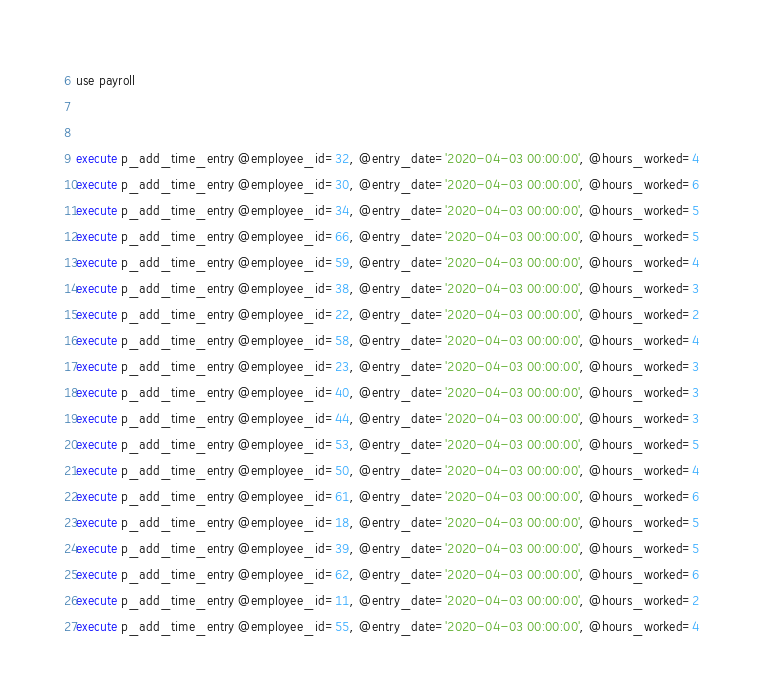<code> <loc_0><loc_0><loc_500><loc_500><_SQL_>use payroll


execute p_add_time_entry @employee_id=32, @entry_date='2020-04-03 00:00:00', @hours_worked=4
execute p_add_time_entry @employee_id=30, @entry_date='2020-04-03 00:00:00', @hours_worked=6
execute p_add_time_entry @employee_id=34, @entry_date='2020-04-03 00:00:00', @hours_worked=5
execute p_add_time_entry @employee_id=66, @entry_date='2020-04-03 00:00:00', @hours_worked=5
execute p_add_time_entry @employee_id=59, @entry_date='2020-04-03 00:00:00', @hours_worked=4
execute p_add_time_entry @employee_id=38, @entry_date='2020-04-03 00:00:00', @hours_worked=3
execute p_add_time_entry @employee_id=22, @entry_date='2020-04-03 00:00:00', @hours_worked=2
execute p_add_time_entry @employee_id=58, @entry_date='2020-04-03 00:00:00', @hours_worked=4
execute p_add_time_entry @employee_id=23, @entry_date='2020-04-03 00:00:00', @hours_worked=3
execute p_add_time_entry @employee_id=40, @entry_date='2020-04-03 00:00:00', @hours_worked=3
execute p_add_time_entry @employee_id=44, @entry_date='2020-04-03 00:00:00', @hours_worked=3
execute p_add_time_entry @employee_id=53, @entry_date='2020-04-03 00:00:00', @hours_worked=5
execute p_add_time_entry @employee_id=50, @entry_date='2020-04-03 00:00:00', @hours_worked=4
execute p_add_time_entry @employee_id=61, @entry_date='2020-04-03 00:00:00', @hours_worked=6
execute p_add_time_entry @employee_id=18, @entry_date='2020-04-03 00:00:00', @hours_worked=5
execute p_add_time_entry @employee_id=39, @entry_date='2020-04-03 00:00:00', @hours_worked=5
execute p_add_time_entry @employee_id=62, @entry_date='2020-04-03 00:00:00', @hours_worked=6
execute p_add_time_entry @employee_id=11, @entry_date='2020-04-03 00:00:00', @hours_worked=2
execute p_add_time_entry @employee_id=55, @entry_date='2020-04-03 00:00:00', @hours_worked=4

</code> 